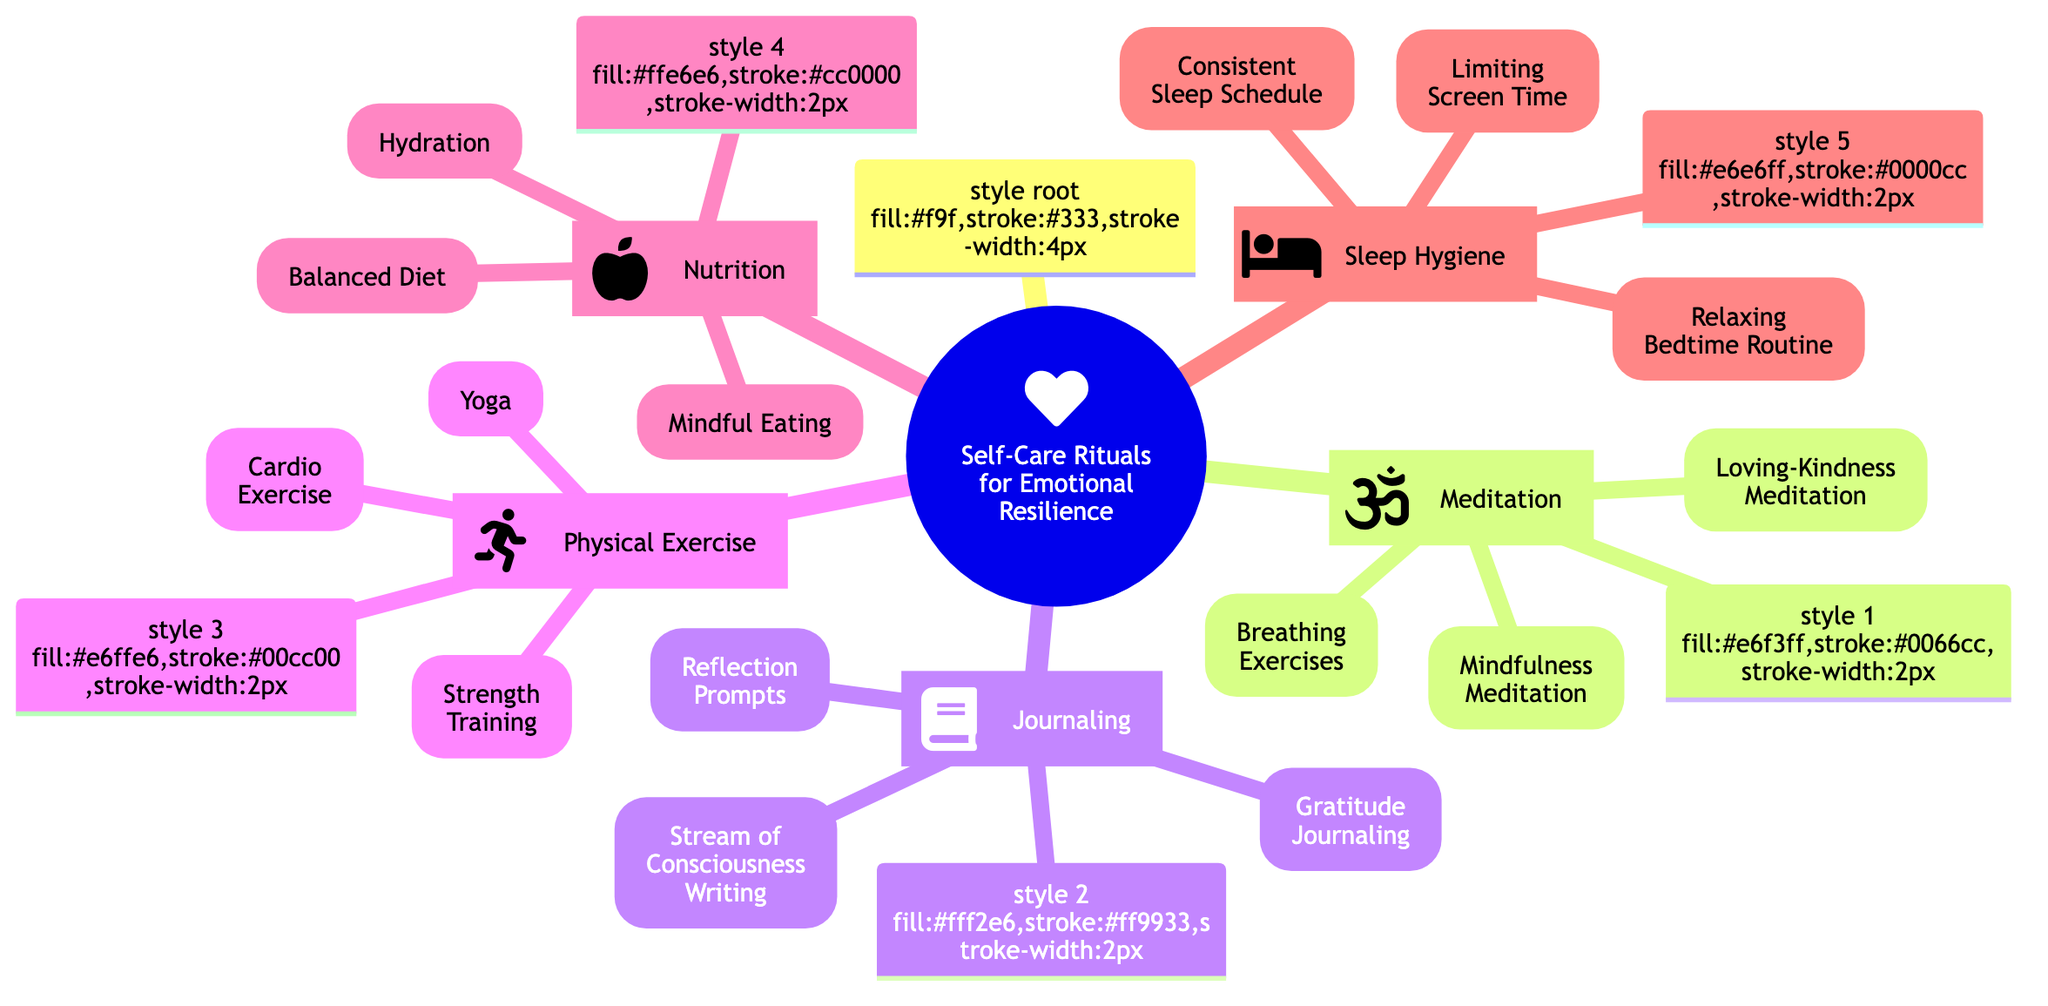What are the three subcategories of Meditation? The diagram shows that Meditation includes three subcategories: Mindfulness Meditation, Loving-Kindness Meditation, and Breathing Exercises.
Answer: Mindfulness Meditation, Loving-Kindness Meditation, Breathing Exercises How many rituals are listed under Physical Exercise? The Physical Exercise category has three listed rituals: Yoga, Cardio Exercise, and Strength Training.
Answer: 3 Which subcategory under Nutrition emphasizes complete meals? The Balanced Diet subcategory under Nutrition emphasizes the importance of complete meals that are rich in various nutrients.
Answer: Balanced Diet What is the recommended duration for Mindfulness Meditation? The diagram specifies that Mindfulness Meditation should be practiced for 10-15 minutes daily.
Answer: 10-15 minutes What daily practice is suggested for Gratitude Journaling? The diagram indicates that Gratitude Journaling involves the daily entry of 3-5 things you are grateful for.
Answer: Daily entry of 3-5 things Which self-care category includes Limiting Screen Time? Limiting Screen Time is included under the Sleep Hygiene category focused on promoting better sleep.
Answer: Sleep Hygiene What constraint does the diagram suggest for the Consistent Sleep Schedule? The Consistent Sleep Schedule emphasizes going to bed and waking up at the same time every day, including weekends.
Answer: Same time every day Which physical exercise activity requires attending a class? The Yoga subcategory suggests attending a local class or using online platforms for practice.
Answer: Yoga How many main categories are focused on in the diagram? The diagram has five main categories focused on self-care rituals for emotional resilience: Meditation, Journaling, Physical Exercise, Nutrition, and Sleep Hygiene.
Answer: 5 What technique is mentioned under Meditation that lasts 5 minutes? Breathing Exercises are mentioned as a technique under Meditation that lasts for 5 minutes.
Answer: Breathing Exercises 